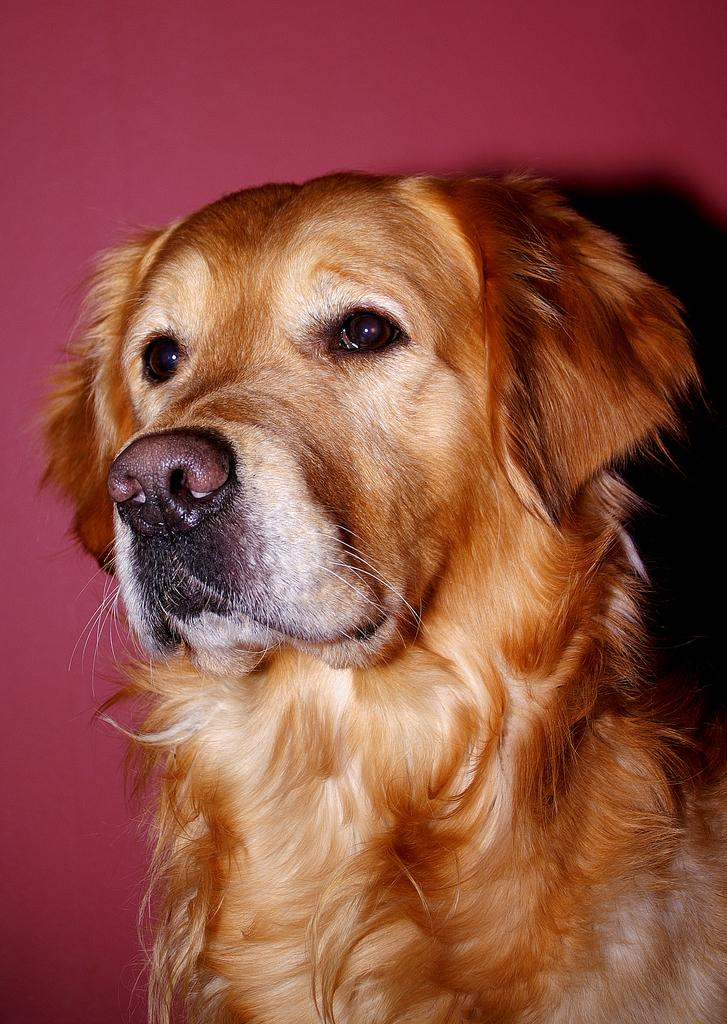What type of animal is present in the image? There is a dog in the image. Can you describe the background of the image? There is a wall painted pink in the background of the image. What type of silver sponge can be seen on the wall in the image? There is no silver sponge present on the wall in the image. The wall is painted pink, but there is no mention of a sponge or anything silver in the image. 